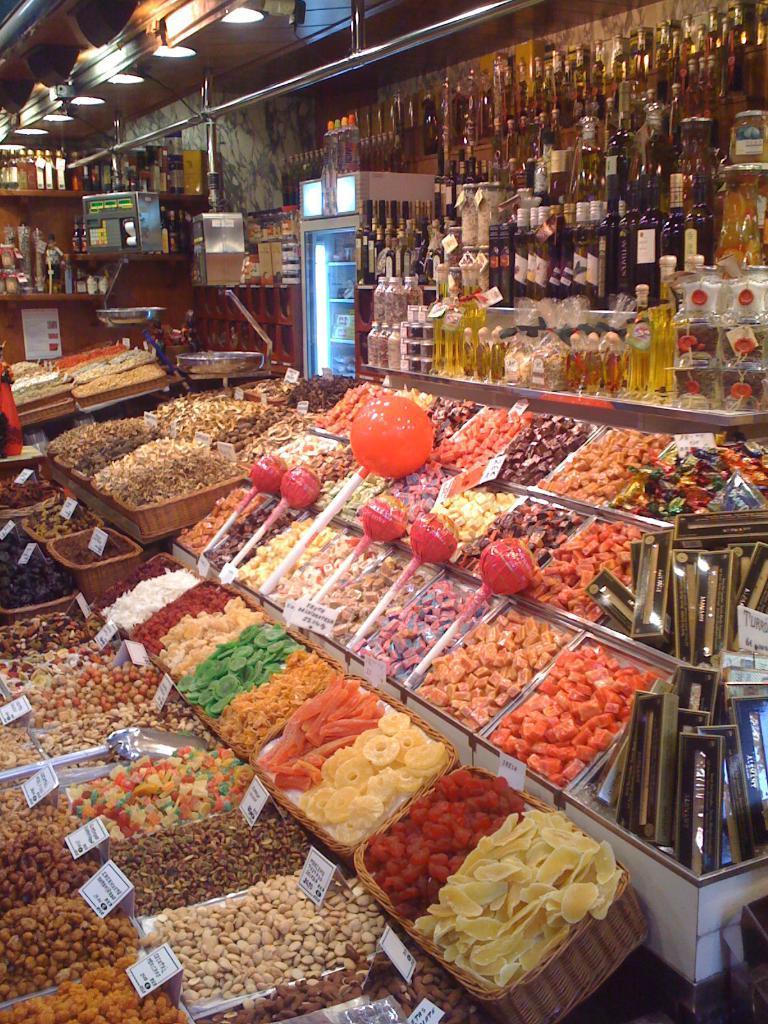Can you describe this image briefly? In this picture there are full of candies placed in the trays. On the top, there are cracks filled with the bottles. On the top, there are lights. 